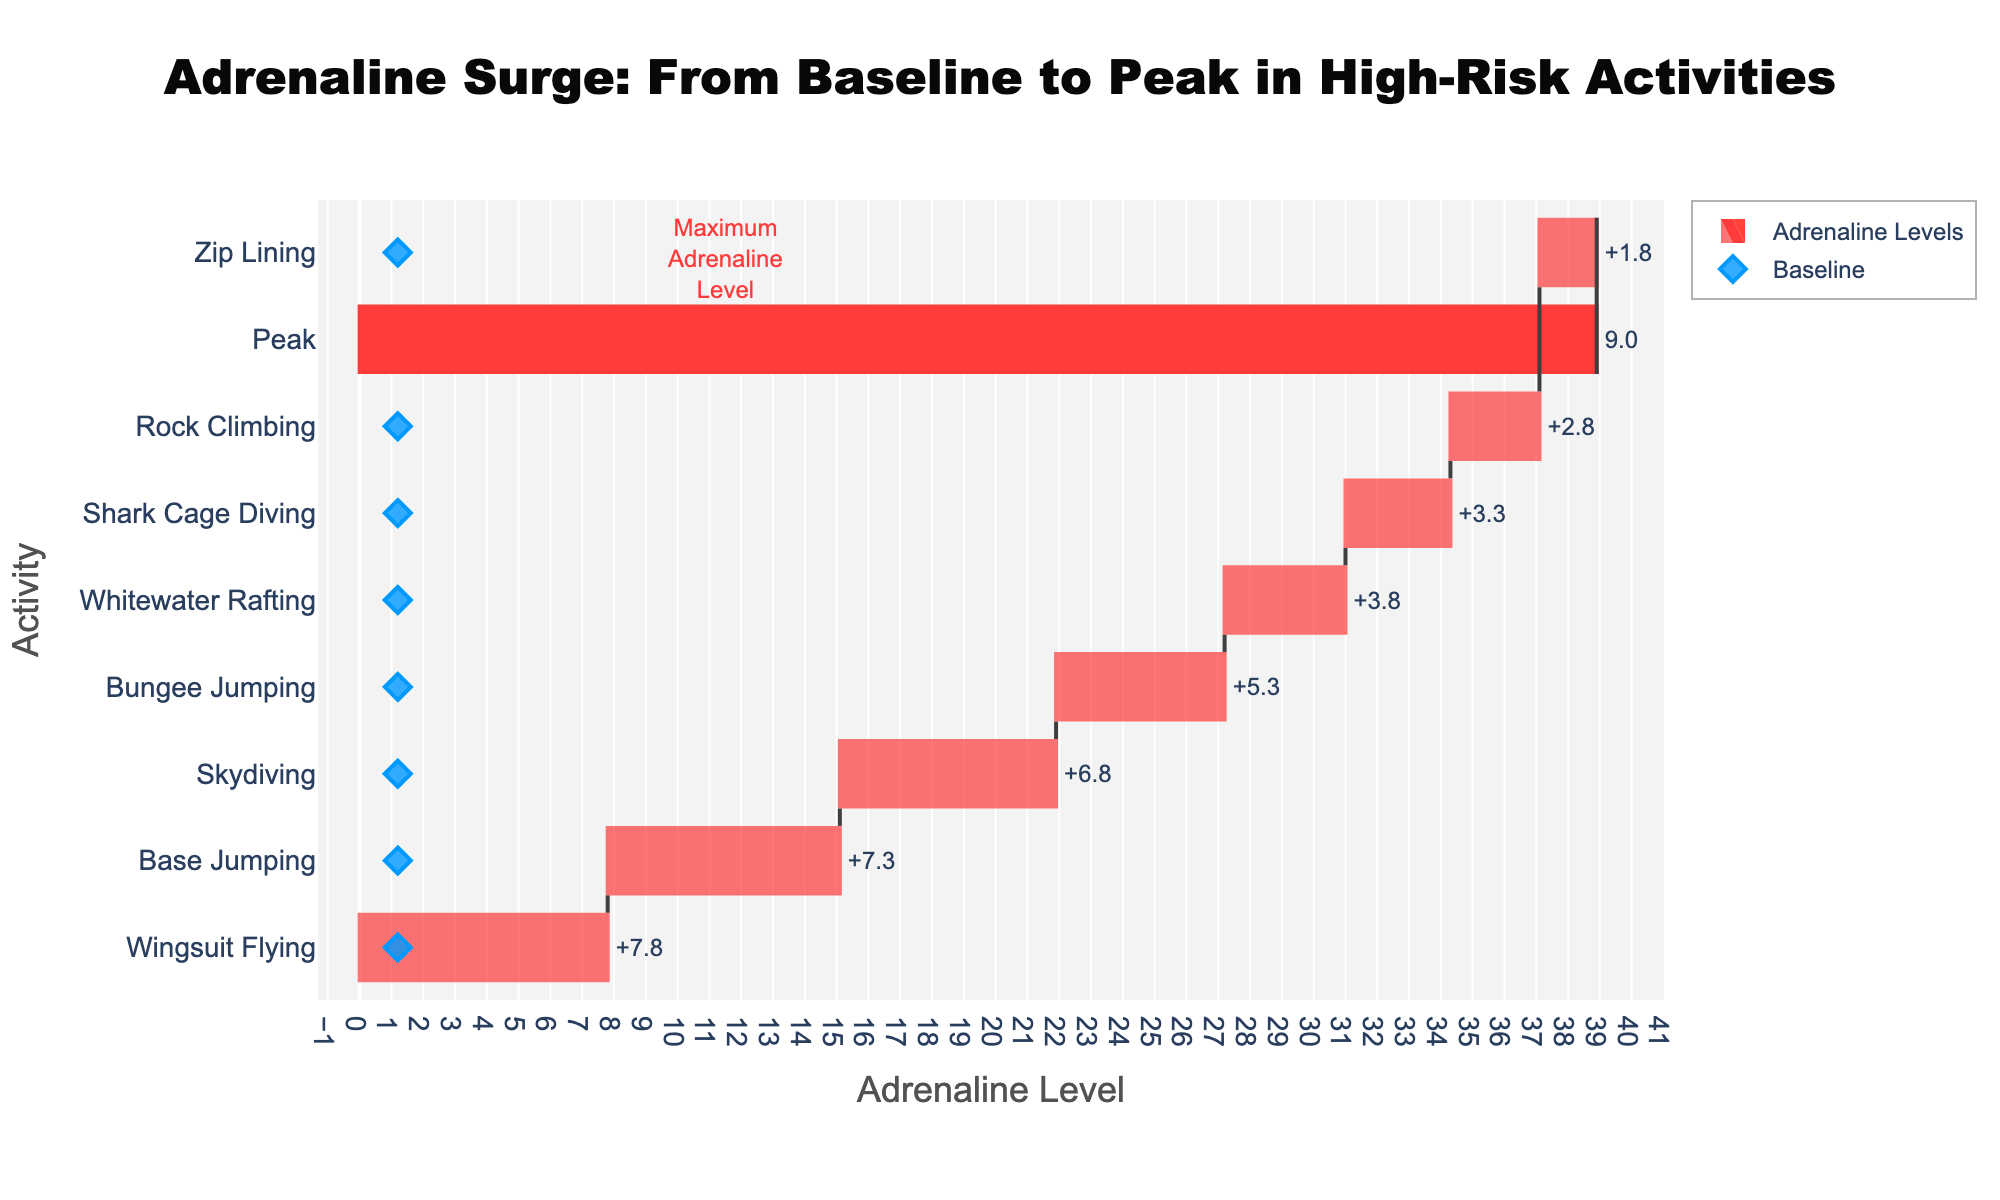What's the title of the figure? The title is located at the top-center of the figure, and it is displayed with a larger font size than other text elements.
Answer: Adrenaline Surge: From Baseline to Peak in High-Risk Activities Which activity has the highest peak adrenaline level? The figure labels the highest peak level with a specific annotation indicating it as the maximum adrenaline level. Based on the chart, Wingsuit Flying has the highest peak adrenaline level.
Answer: Wingsuit Flying What is the baseline adrenaline level for all activities? The baseline level is represented by diamond markers along the horizontal axis, and each activity shows a consistent baseline level.
Answer: 1.2 How much does the adrenaline level increase while skydiving? Referring to the text labels on the horizontal bar for Skydiving, the increase in adrenaline level is highlighted.
Answer: 6.8 Which activity shows the smallest increase in adrenaline level? By examining the horizontal length of the segments (bars) in the waterfall chart and the corresponding text labels, we can identify the smallest increase.
Answer: Zip Lining Compare the peak adrenaline levels of Skydiving and Bungee Jumping. Which is higher? By comparing the lengths of the horizontal bars and peak values displayed in the figure, we see Skydiving’s peak level is greater than Bungee Jumping’s.
Answer: Skydiving Calculate the average peak adrenaline level across all activities. Summing the peak adrenaline levels for all activities (8.0 + 6.5 + 5.0 + 4.0 + 3.0 + 4.5 + 8.5 + 9.0) and dividing by the number of activities (8) yields the average peak level.
Answer: 6.1 What is the difference in peak adrenaline levels between Rock Climbing and Shark Cage Diving? Subtract the peak level of Shark Cage Diving from Rock Climbing's peak level (4.5 - 4.0) to find the difference.
Answer: 0.5 Which activity's adrenaline increase is closest to the increase of Whitewater Rafting? Comparing the values representing the increase in adrenaline, we look for the activity that has an adrenaline increase closest to Whitewater Rafting’s increase of 3.8.
Answer: Shark Cage Diving How many activities have a peak adrenaline level greater than 5.0? By counting the activities with peak levels indicated above 5.0, we determine the number of such activities.
Answer: 5 